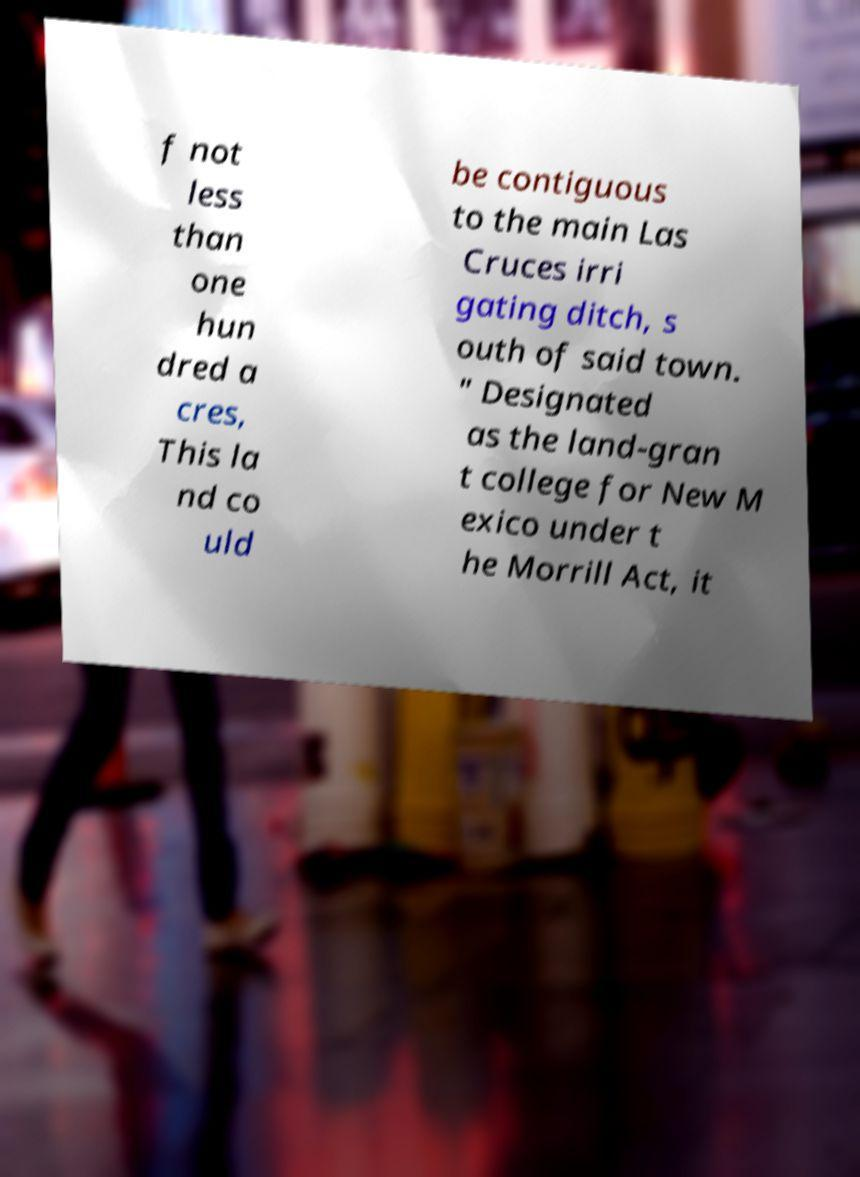Please read and relay the text visible in this image. What does it say? f not less than one hun dred a cres, This la nd co uld be contiguous to the main Las Cruces irri gating ditch, s outh of said town. " Designated as the land-gran t college for New M exico under t he Morrill Act, it 